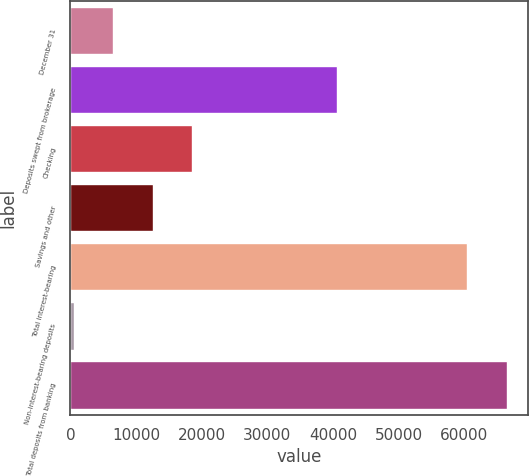<chart> <loc_0><loc_0><loc_500><loc_500><bar_chart><fcel>December 31<fcel>Deposits swept from brokerage<fcel>Checking<fcel>Savings and other<fcel>Total interest-bearing<fcel>Non-interest-bearing deposits<fcel>Total deposits from banking<nl><fcel>6512.9<fcel>40617<fcel>18588.7<fcel>12550.8<fcel>60379<fcel>475<fcel>66416.9<nl></chart> 